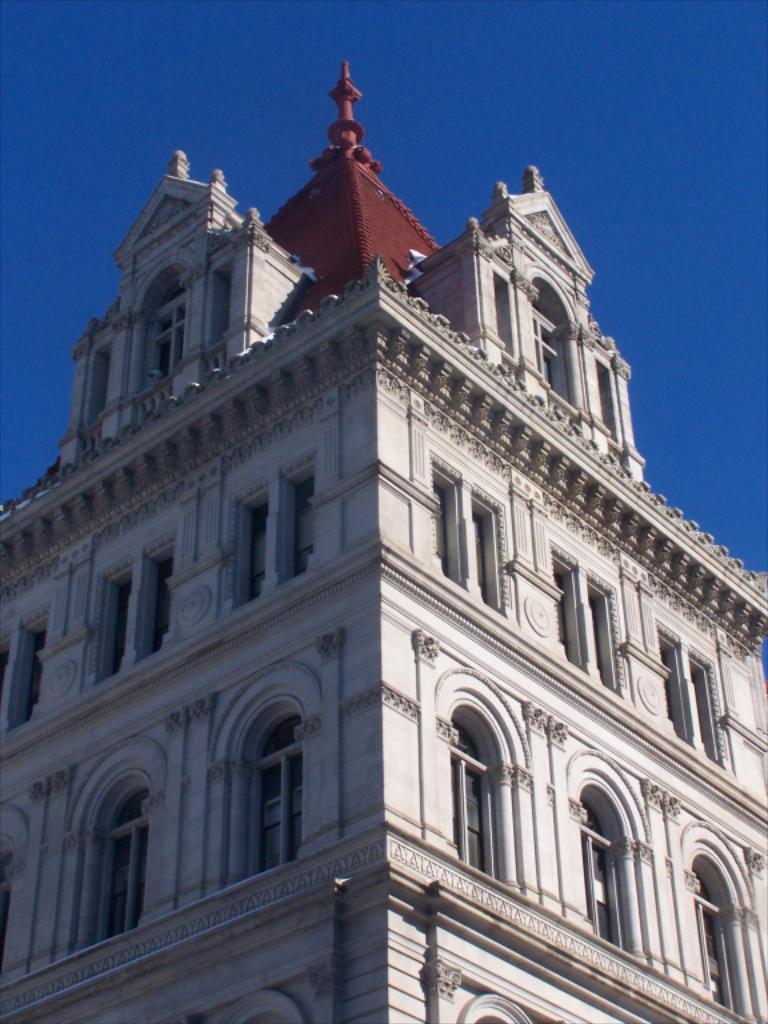Please provide a concise description of this image. In this image we can see a building, there are some windows, also we can see the sky. 